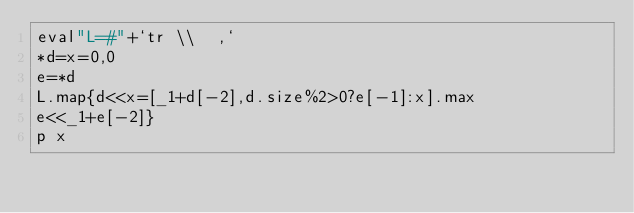<code> <loc_0><loc_0><loc_500><loc_500><_Ruby_>eval"L=#"+`tr \\  ,`
*d=x=0,0
e=*d
L.map{d<<x=[_1+d[-2],d.size%2>0?e[-1]:x].max
e<<_1+e[-2]}
p x</code> 